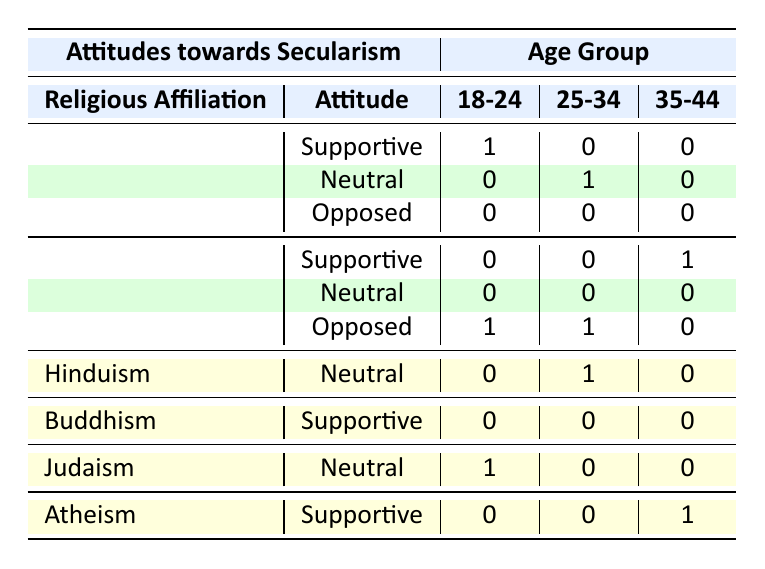What is the attitude of Christians aged 18-24 towards secularism? The table shows that within the Christian religious affiliation for the age group 18-24, there is 1 count classified as "Supportive." Therefore, Christians aged 18-24 are supportive of secularism.
Answer: Supportive How many individuals from the Islamic faith oppose secularism between the ages of 18-34? For Islam in the age groups 18-24 and 25-34, the counts opposing secularism are 1 (for 18-24) and 1 (for 25-34). Adding these together gives a total of 1 + 1 = 2 individuals opposing secularism in this age group.
Answer: 2 Is there a supportive attitude towards secularism from individuals affiliated with Buddhism? The table indicates that there are no individuals from Buddhism who are classified as "Supportive" in any age group, as all counts for Buddhism are zero for the supportive attitude. Therefore, the statement is false.
Answer: No What is the total number of individuals who have a neutral attitude towards secularism in the age group 25-34? In the age group of 25-34, the following religious affiliations have a neutral attitude: 1 from Christianity and 1 from Hinduism. Adding these gives 1 + 1 = 2 individuals with a neutral attitude.
Answer: 2 How does the attitude towards secularism differ between Christians and Muslims in the age group of 25-34? According to the table, Christians aged 25-34 show a "Neutral" attitude (1 count), while Muslims of the same age group show an "Opposed" attitude (1 count). This determines that Christians are neutral, whereas Muslims are opposed.
Answer: Christians: Neutral, Muslims: Opposed Compare the supportive attitudes towards secularism in the age group 35-44 between Islam and Atheism. The table indicates that within the 35-44 age group, Islam has 1 count supportive, while Atheism also has 1 count which is supportive. Therefore, they are equal.
Answer: Equal support from both Which religious affiliation has the most neutral attitudes towards secularism in general? By examining the table, both Christianity and Hinduism, along with Judaism, have instances of neutral attitudes but in different age groups. Counting those age groups: Christianity has 1, Hinduism has 1, and Judaism has 1 for neutrality, resulting in three religious affiliations having neutral attitudes, but none is more than the rest.
Answer: All are equal What is the total number of people in the recorded data who have a neutral attitude towards secularism? The total number of neutral attitudes is gathered from all relevant categories: 1 from Christianity (25-34), 1 from Islam (none), 1 from Hinduism (25-34), and 1 from Judaism (18-24), summing these gives 1 + 1 + 1 + 1 = 4.
Answer: 4 